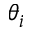<formula> <loc_0><loc_0><loc_500><loc_500>\theta _ { i }</formula> 